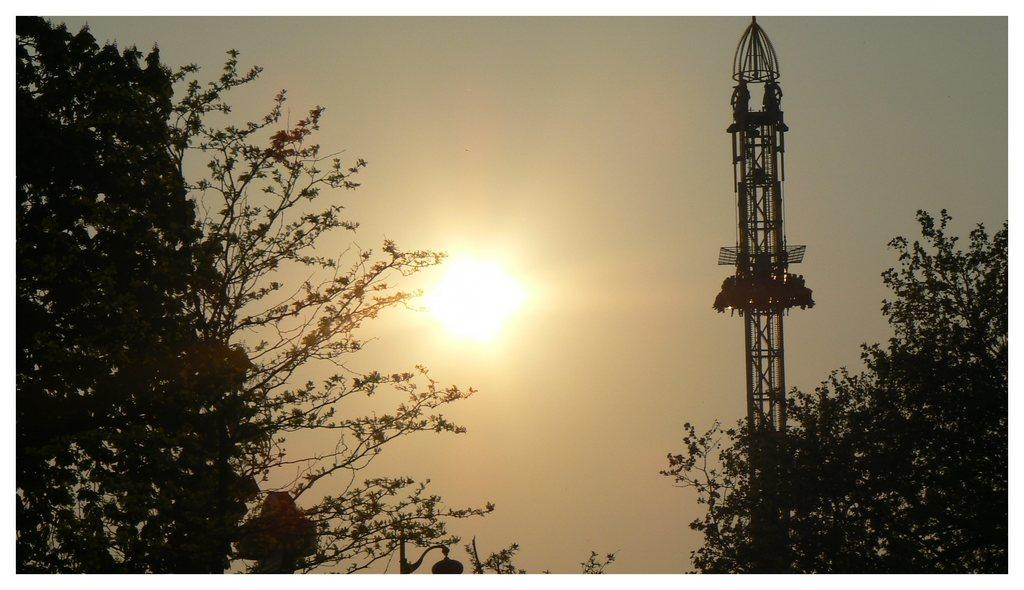What is the main subject in the center of the image? There is a sun in the center of the image. What can be seen in the background of the image? There are trees, lights, poles, and a tower in the background of the image. What is visible at the top of the image? The sky is visible at the top of the image. What type of legal advice is the sun providing to the trees in the image? The sun is not providing legal advice to the trees in the image, as it is a celestial body and not a lawyer. 